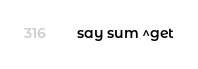Convert code to text. <code><loc_0><loc_0><loc_500><loc_500><_Perl_>say sum ^get</code> 